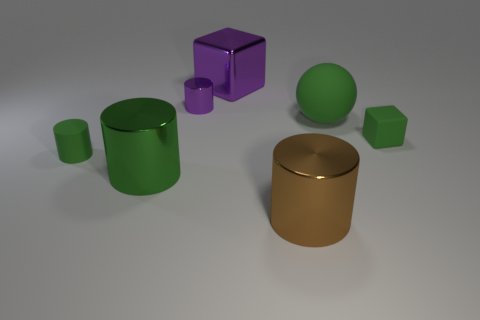Does this arrangement of objects suggest any particular theme or concept? The arrangement of objects might be interpreted in various ways. It could represent a simplistic, almost minimalist approach to design, focusing on geometric forms and a primary color scheme. The objects may also symbolize structure and organization, where each shape and color has its own place and purpose. If we think abstractly, it might even reflect on individuality and diversity—despite differences in shapes and colors, they coexist harmoniously. 